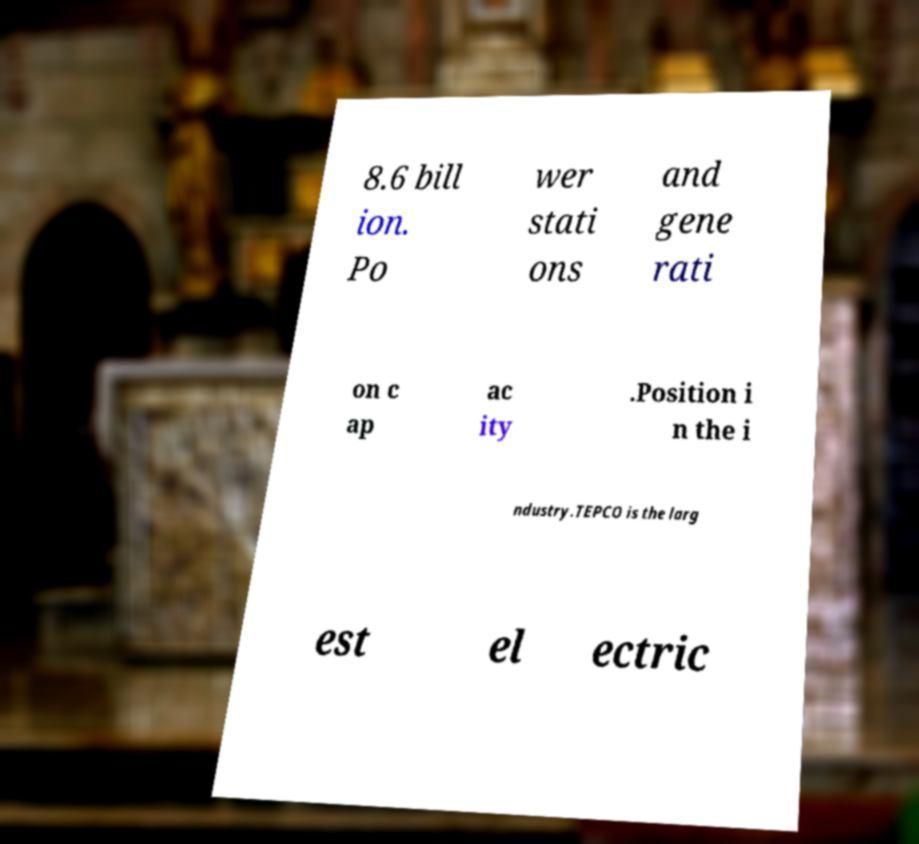What messages or text are displayed in this image? I need them in a readable, typed format. 8.6 bill ion. Po wer stati ons and gene rati on c ap ac ity .Position i n the i ndustry.TEPCO is the larg est el ectric 